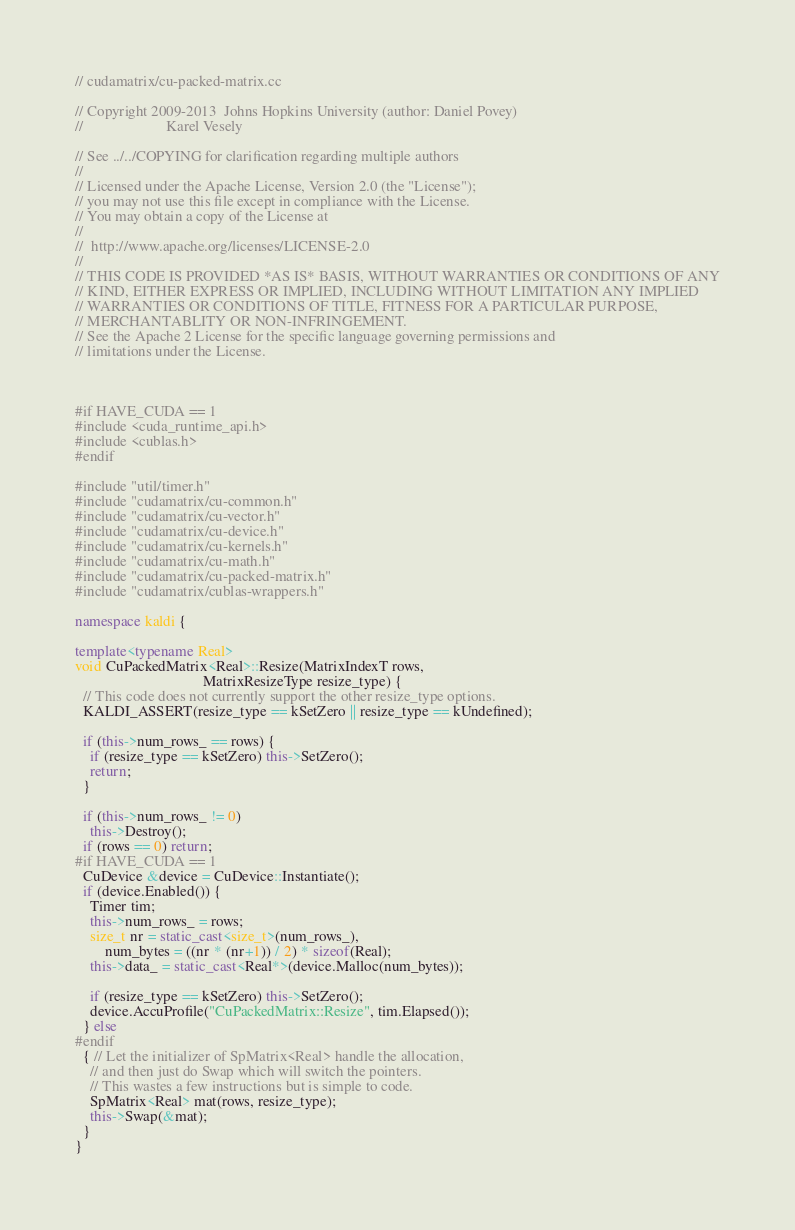<code> <loc_0><loc_0><loc_500><loc_500><_C++_>// cudamatrix/cu-packed-matrix.cc

// Copyright 2009-2013  Johns Hopkins University (author: Daniel Povey)
//                      Karel Vesely

// See ../../COPYING for clarification regarding multiple authors
//
// Licensed under the Apache License, Version 2.0 (the "License");
// you may not use this file except in compliance with the License.
// You may obtain a copy of the License at
//
//  http://www.apache.org/licenses/LICENSE-2.0
//
// THIS CODE IS PROVIDED *AS IS* BASIS, WITHOUT WARRANTIES OR CONDITIONS OF ANY
// KIND, EITHER EXPRESS OR IMPLIED, INCLUDING WITHOUT LIMITATION ANY IMPLIED
// WARRANTIES OR CONDITIONS OF TITLE, FITNESS FOR A PARTICULAR PURPOSE,
// MERCHANTABLITY OR NON-INFRINGEMENT.
// See the Apache 2 License for the specific language governing permissions and
// limitations under the License.



#if HAVE_CUDA == 1
#include <cuda_runtime_api.h>
#include <cublas.h>
#endif

#include "util/timer.h"
#include "cudamatrix/cu-common.h"
#include "cudamatrix/cu-vector.h"
#include "cudamatrix/cu-device.h"
#include "cudamatrix/cu-kernels.h"
#include "cudamatrix/cu-math.h"
#include "cudamatrix/cu-packed-matrix.h"
#include "cudamatrix/cublas-wrappers.h"

namespace kaldi {

template<typename Real>
void CuPackedMatrix<Real>::Resize(MatrixIndexT rows,
                                  MatrixResizeType resize_type) {
  // This code does not currently support the other resize_type options.
  KALDI_ASSERT(resize_type == kSetZero || resize_type == kUndefined);

  if (this->num_rows_ == rows) {
    if (resize_type == kSetZero) this->SetZero();
    return;
  }

  if (this->num_rows_ != 0)
    this->Destroy();
  if (rows == 0) return;  
#if HAVE_CUDA == 1
  CuDevice &device = CuDevice::Instantiate();
  if (device.Enabled()) {
    Timer tim;
    this->num_rows_ = rows;
    size_t nr = static_cast<size_t>(num_rows_),
        num_bytes = ((nr * (nr+1)) / 2) * sizeof(Real);
    this->data_ = static_cast<Real*>(device.Malloc(num_bytes));

    if (resize_type == kSetZero) this->SetZero();
    device.AccuProfile("CuPackedMatrix::Resize", tim.Elapsed());    
  } else
#endif
  { // Let the initializer of SpMatrix<Real> handle the allocation,
    // and then just do Swap which will switch the pointers.
    // This wastes a few instructions but is simple to code.
    SpMatrix<Real> mat(rows, resize_type);
    this->Swap(&mat);
  }
}
</code> 